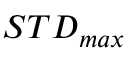<formula> <loc_0><loc_0><loc_500><loc_500>S T D _ { \max }</formula> 